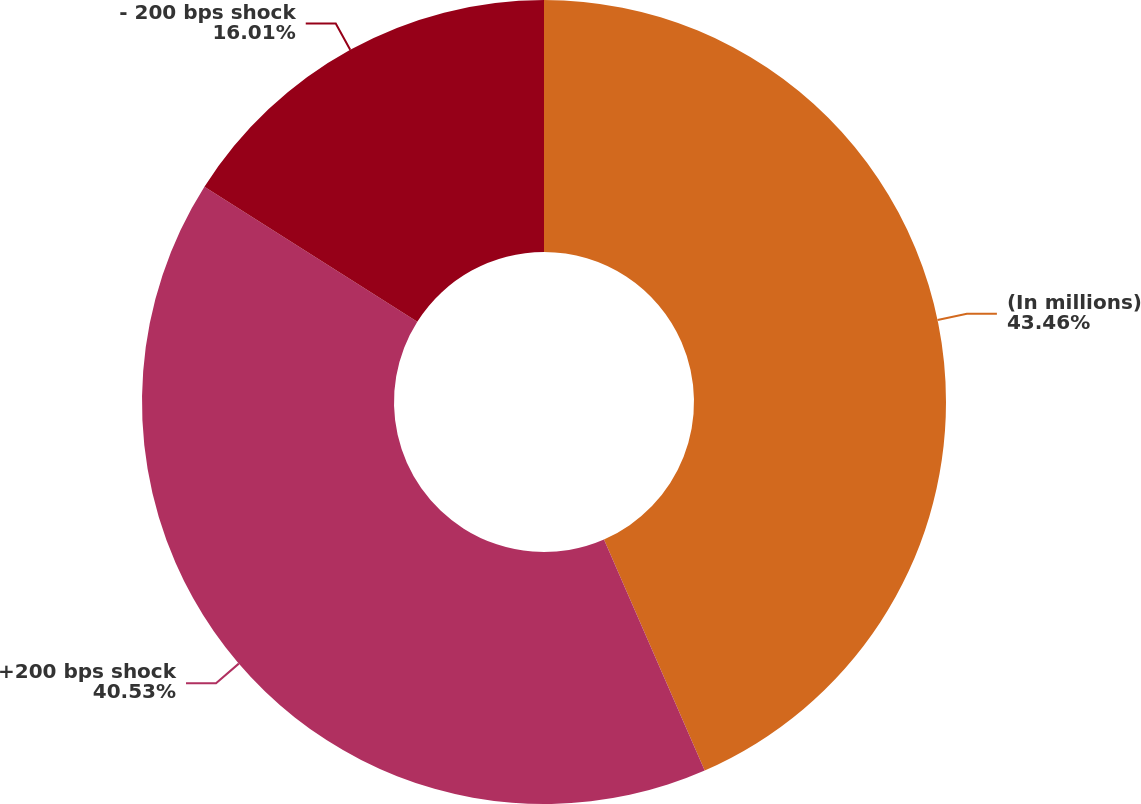Convert chart. <chart><loc_0><loc_0><loc_500><loc_500><pie_chart><fcel>(In millions)<fcel>+200 bps shock<fcel>- 200 bps shock<nl><fcel>43.45%<fcel>40.53%<fcel>16.01%<nl></chart> 